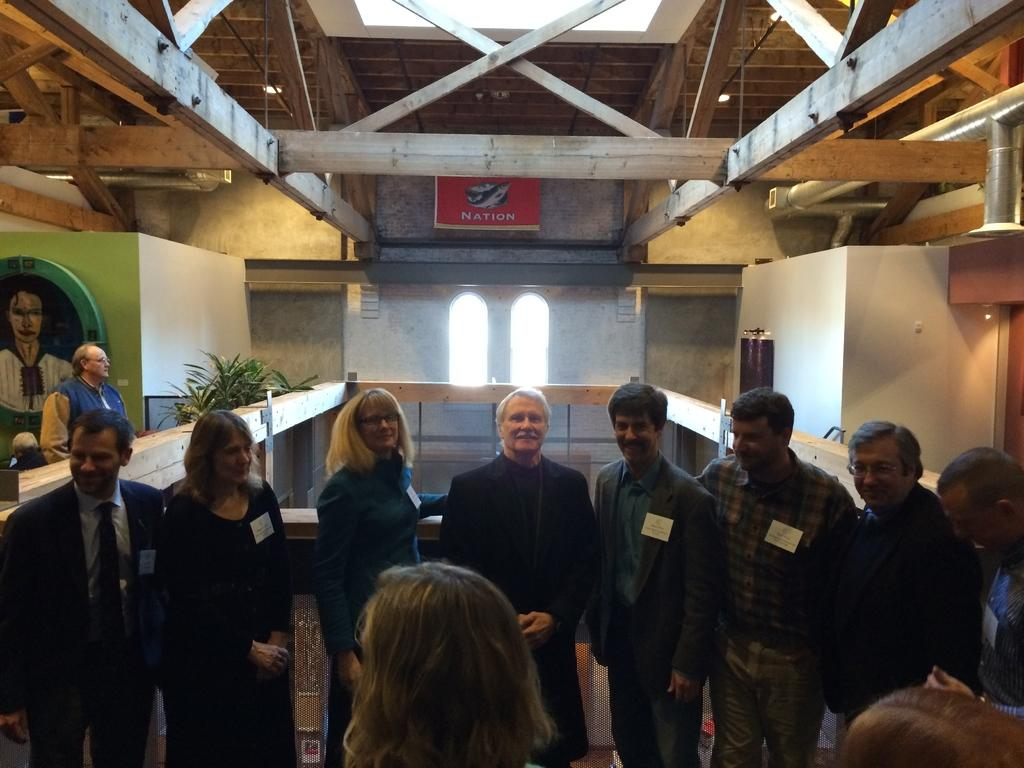How many people are in the image? There is a group of people in the image, but the exact number cannot be determined from the provided facts. What can be seen in the background of the image? In the background of the image, there are planets, a screen, a board, a frame, lights, a window, and a wall. What might be used for displaying information or visuals in the image? The screen in the background of the image might be used for displaying information or visuals. What type of bomb can be seen in the image? There is no bomb present in the image. How much dust can be seen on the board in the image? There is no mention of dust in the image, and the board's condition cannot be determined from the provided facts. 